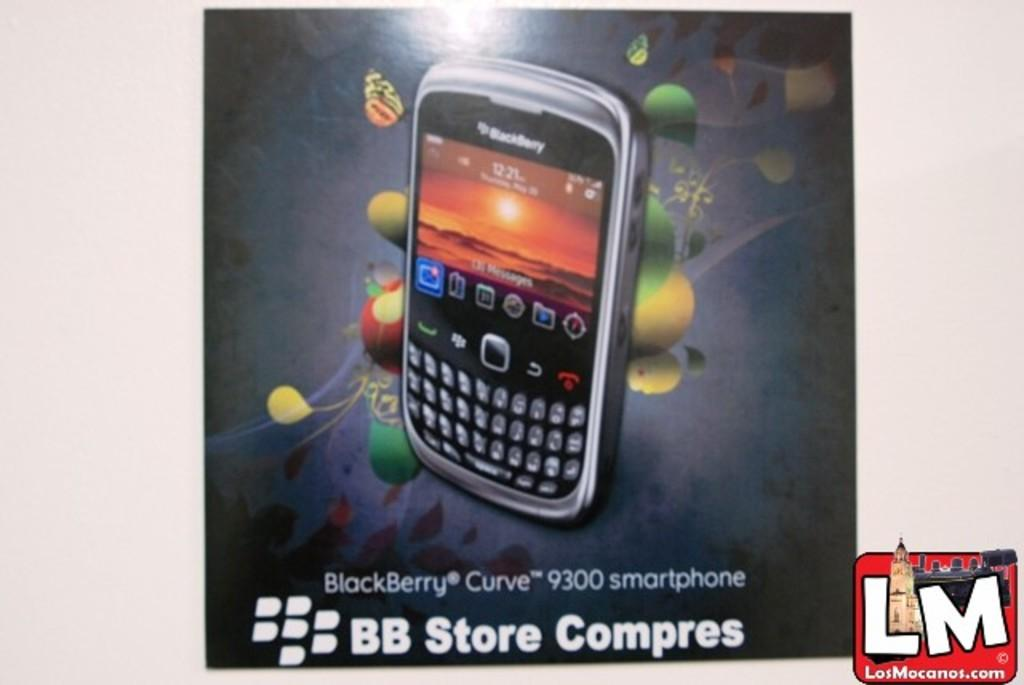Provide a one-sentence caption for the provided image. An advertisement for a BlackBerry Curve 9300 smartphone. 